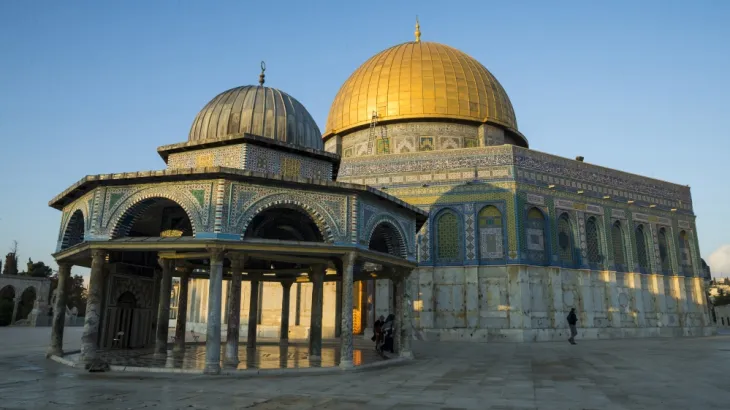Describe the following image. The image captures the Al Aqsa Mosque, a pivotal site in Jerusalem and a jewel of Islamic architecture. Recognizable by its striking gold-plated Dome of the Rock and an adjacent series of arches and intricate mosaics. This mosque is not only a religious symbol but also serves as a testament to centuries of architectural evolution and the cultural intermingling in one of the world’s oldest cities. The image, taken during golden hour, enriches the warm tones of the stone and tiles, giving the site a glow that speaks to its spiritual significance. 